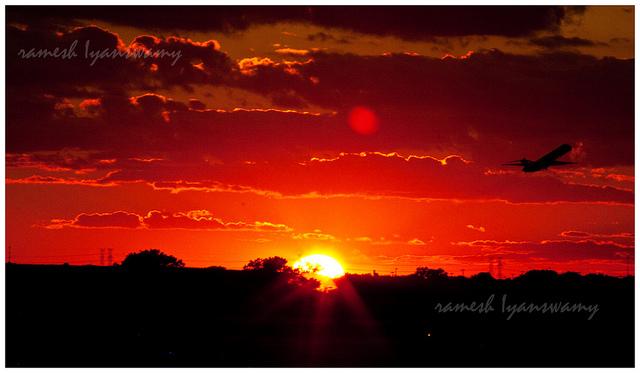Is it daytime?
Short answer required. Yes. Where is the sun in the picture?
Give a very brief answer. Horizon. Is it day or night?
Give a very brief answer. Night. What color is the sky?
Give a very brief answer. Red. What is the object flying in the sky?
Quick response, please. Plane. What shape are the clouds?
Keep it brief. Squiggles. What is in the air?
Concise answer only. Airplane. 